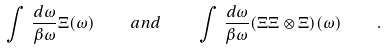<formula> <loc_0><loc_0><loc_500><loc_500>\int \, \frac { d \omega } { \beta \omega } \Xi ( \omega ) \quad a n d \quad \int \, \frac { d \omega } { \beta \omega } ( \Xi \Xi \otimes \Xi ) ( \omega ) \quad .</formula> 